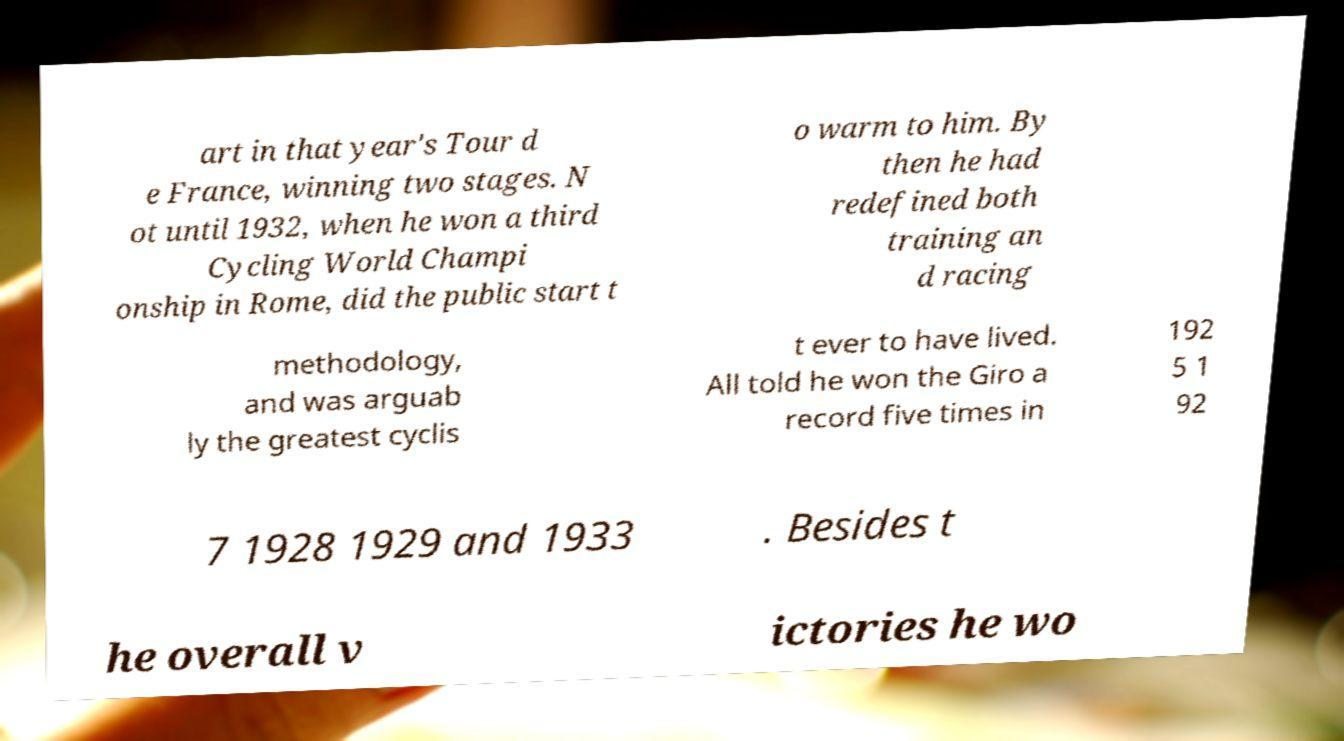I need the written content from this picture converted into text. Can you do that? art in that year's Tour d e France, winning two stages. N ot until 1932, when he won a third Cycling World Champi onship in Rome, did the public start t o warm to him. By then he had redefined both training an d racing methodology, and was arguab ly the greatest cyclis t ever to have lived. All told he won the Giro a record five times in 192 5 1 92 7 1928 1929 and 1933 . Besides t he overall v ictories he wo 